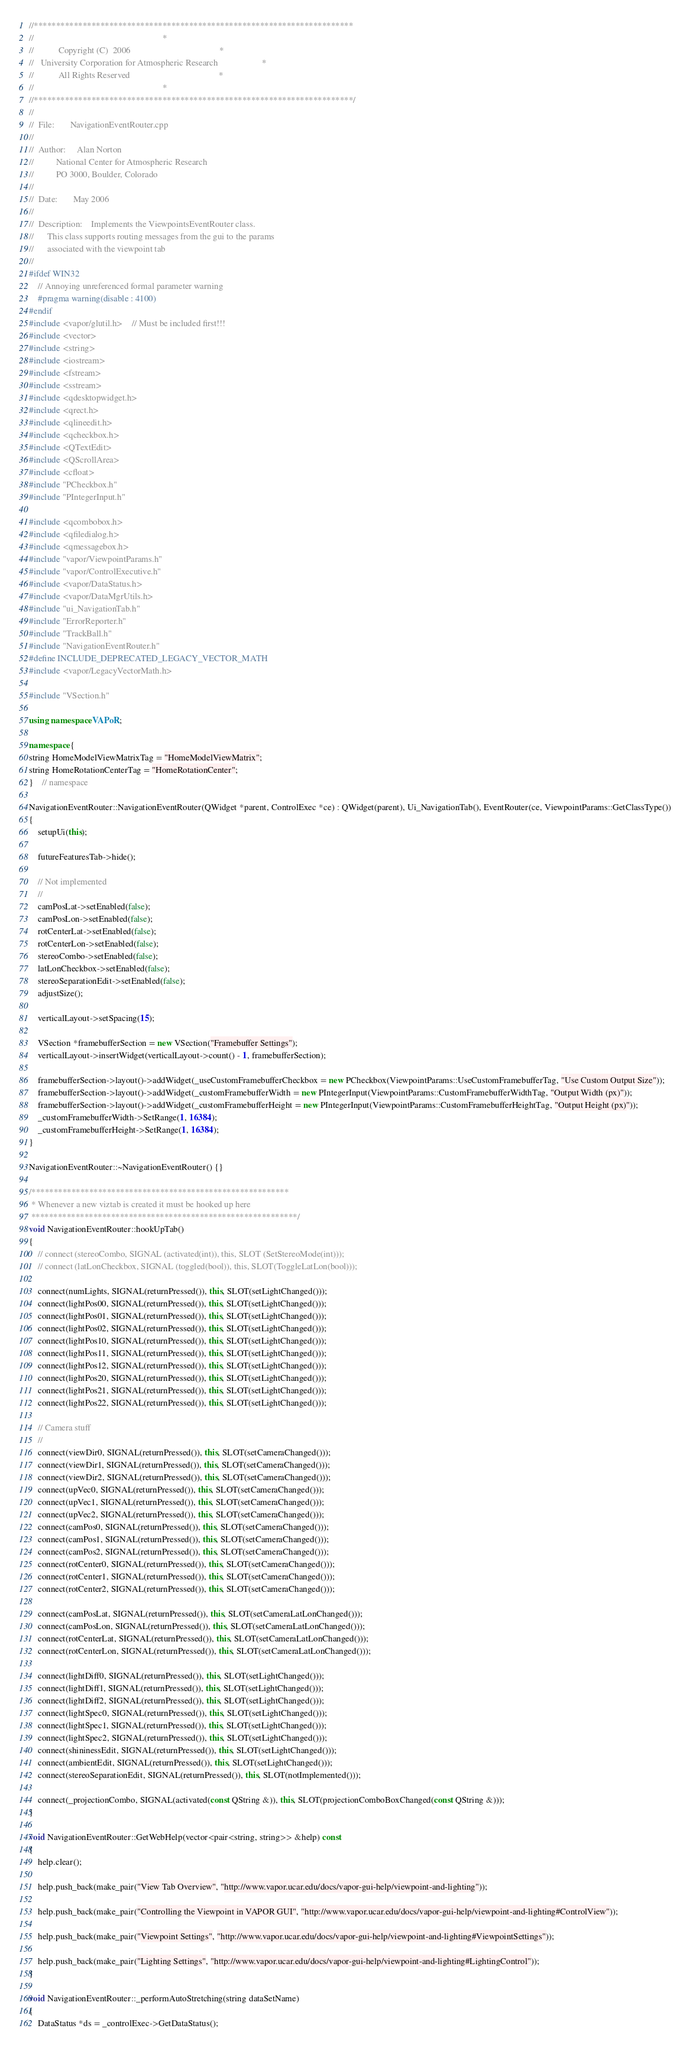Convert code to text. <code><loc_0><loc_0><loc_500><loc_500><_C++_>//************************************************************************
//															*
//			 Copyright (C)  2006										*
//	 University Corporation for Atmospheric Research					*
//			 All Rights Reserved										*
//															*
//************************************************************************/
//
//	File:		NavigationEventRouter.cpp
//
//	Author:		Alan Norton
//			National Center for Atmospheric Research
//			PO 3000, Boulder, Colorado
//
//	Date:		May 2006
//
//	Description:	Implements the ViewpointsEventRouter class.
//		This class supports routing messages from the gui to the params
//		associated with the viewpoint tab
//
#ifdef WIN32
    // Annoying unreferenced formal parameter warning
    #pragma warning(disable : 4100)
#endif
#include <vapor/glutil.h>    // Must be included first!!!
#include <vector>
#include <string>
#include <iostream>
#include <fstream>
#include <sstream>
#include <qdesktopwidget.h>
#include <qrect.h>
#include <qlineedit.h>
#include <qcheckbox.h>
#include <QTextEdit>
#include <QScrollArea>
#include <cfloat>
#include "PCheckbox.h"
#include "PIntegerInput.h"

#include <qcombobox.h>
#include <qfiledialog.h>
#include <qmessagebox.h>
#include "vapor/ViewpointParams.h"
#include "vapor/ControlExecutive.h"
#include <vapor/DataStatus.h>
#include <vapor/DataMgrUtils.h>
#include "ui_NavigationTab.h"
#include "ErrorReporter.h"
#include "TrackBall.h"
#include "NavigationEventRouter.h"
#define INCLUDE_DEPRECATED_LEGACY_VECTOR_MATH
#include <vapor/LegacyVectorMath.h>

#include "VSection.h"

using namespace VAPoR;

namespace {
string HomeModelViewMatrixTag = "HomeModelViewMatrix";
string HomeRotationCenterTag = "HomeRotationCenter";
}    // namespace

NavigationEventRouter::NavigationEventRouter(QWidget *parent, ControlExec *ce) : QWidget(parent), Ui_NavigationTab(), EventRouter(ce, ViewpointParams::GetClassType())
{
    setupUi(this);

    futureFeaturesTab->hide();

    // Not implemented
    //
    camPosLat->setEnabled(false);
    camPosLon->setEnabled(false);
    rotCenterLat->setEnabled(false);
    rotCenterLon->setEnabled(false);
    stereoCombo->setEnabled(false);
    latLonCheckbox->setEnabled(false);
    stereoSeparationEdit->setEnabled(false);
    adjustSize();

    verticalLayout->setSpacing(15);

    VSection *framebufferSection = new VSection("Framebuffer Settings");
    verticalLayout->insertWidget(verticalLayout->count() - 1, framebufferSection);

    framebufferSection->layout()->addWidget(_useCustomFramebufferCheckbox = new PCheckbox(ViewpointParams::UseCustomFramebufferTag, "Use Custom Output Size"));
    framebufferSection->layout()->addWidget(_customFramebufferWidth = new PIntegerInput(ViewpointParams::CustomFramebufferWidthTag, "Output Width (px)"));
    framebufferSection->layout()->addWidget(_customFramebufferHeight = new PIntegerInput(ViewpointParams::CustomFramebufferHeightTag, "Output Height (px)"));
    _customFramebufferWidth->SetRange(1, 16384);
    _customFramebufferHeight->SetRange(1, 16384);
}

NavigationEventRouter::~NavigationEventRouter() {}

/**********************************************************
 * Whenever a new viztab is created it must be hooked up here
 ************************************************************/
void NavigationEventRouter::hookUpTab()
{
    // connect (stereoCombo, SIGNAL (activated(int)), this, SLOT (SetStereoMode(int)));
    // connect (latLonCheckbox, SIGNAL (toggled(bool)), this, SLOT(ToggleLatLon(bool)));

    connect(numLights, SIGNAL(returnPressed()), this, SLOT(setLightChanged()));
    connect(lightPos00, SIGNAL(returnPressed()), this, SLOT(setLightChanged()));
    connect(lightPos01, SIGNAL(returnPressed()), this, SLOT(setLightChanged()));
    connect(lightPos02, SIGNAL(returnPressed()), this, SLOT(setLightChanged()));
    connect(lightPos10, SIGNAL(returnPressed()), this, SLOT(setLightChanged()));
    connect(lightPos11, SIGNAL(returnPressed()), this, SLOT(setLightChanged()));
    connect(lightPos12, SIGNAL(returnPressed()), this, SLOT(setLightChanged()));
    connect(lightPos20, SIGNAL(returnPressed()), this, SLOT(setLightChanged()));
    connect(lightPos21, SIGNAL(returnPressed()), this, SLOT(setLightChanged()));
    connect(lightPos22, SIGNAL(returnPressed()), this, SLOT(setLightChanged()));

    // Camera stuff
    //
    connect(viewDir0, SIGNAL(returnPressed()), this, SLOT(setCameraChanged()));
    connect(viewDir1, SIGNAL(returnPressed()), this, SLOT(setCameraChanged()));
    connect(viewDir2, SIGNAL(returnPressed()), this, SLOT(setCameraChanged()));
    connect(upVec0, SIGNAL(returnPressed()), this, SLOT(setCameraChanged()));
    connect(upVec1, SIGNAL(returnPressed()), this, SLOT(setCameraChanged()));
    connect(upVec2, SIGNAL(returnPressed()), this, SLOT(setCameraChanged()));
    connect(camPos0, SIGNAL(returnPressed()), this, SLOT(setCameraChanged()));
    connect(camPos1, SIGNAL(returnPressed()), this, SLOT(setCameraChanged()));
    connect(camPos2, SIGNAL(returnPressed()), this, SLOT(setCameraChanged()));
    connect(rotCenter0, SIGNAL(returnPressed()), this, SLOT(setCameraChanged()));
    connect(rotCenter1, SIGNAL(returnPressed()), this, SLOT(setCameraChanged()));
    connect(rotCenter2, SIGNAL(returnPressed()), this, SLOT(setCameraChanged()));

    connect(camPosLat, SIGNAL(returnPressed()), this, SLOT(setCameraLatLonChanged()));
    connect(camPosLon, SIGNAL(returnPressed()), this, SLOT(setCameraLatLonChanged()));
    connect(rotCenterLat, SIGNAL(returnPressed()), this, SLOT(setCameraLatLonChanged()));
    connect(rotCenterLon, SIGNAL(returnPressed()), this, SLOT(setCameraLatLonChanged()));

    connect(lightDiff0, SIGNAL(returnPressed()), this, SLOT(setLightChanged()));
    connect(lightDiff1, SIGNAL(returnPressed()), this, SLOT(setLightChanged()));
    connect(lightDiff2, SIGNAL(returnPressed()), this, SLOT(setLightChanged()));
    connect(lightSpec0, SIGNAL(returnPressed()), this, SLOT(setLightChanged()));
    connect(lightSpec1, SIGNAL(returnPressed()), this, SLOT(setLightChanged()));
    connect(lightSpec2, SIGNAL(returnPressed()), this, SLOT(setLightChanged()));
    connect(shininessEdit, SIGNAL(returnPressed()), this, SLOT(setLightChanged()));
    connect(ambientEdit, SIGNAL(returnPressed()), this, SLOT(setLightChanged()));
    connect(stereoSeparationEdit, SIGNAL(returnPressed()), this, SLOT(notImplemented()));

    connect(_projectionCombo, SIGNAL(activated(const QString &)), this, SLOT(projectionComboBoxChanged(const QString &)));
}

void NavigationEventRouter::GetWebHelp(vector<pair<string, string>> &help) const
{
    help.clear();

    help.push_back(make_pair("View Tab Overview", "http://www.vapor.ucar.edu/docs/vapor-gui-help/viewpoint-and-lighting"));

    help.push_back(make_pair("Controlling the Viewpoint in VAPOR GUI", "http://www.vapor.ucar.edu/docs/vapor-gui-help/viewpoint-and-lighting#ControlView"));

    help.push_back(make_pair("Viewpoint Settings", "http://www.vapor.ucar.edu/docs/vapor-gui-help/viewpoint-and-lighting#ViewpointSettings"));

    help.push_back(make_pair("Lighting Settings", "http://www.vapor.ucar.edu/docs/vapor-gui-help/viewpoint-and-lighting#LightingControl"));
}

void NavigationEventRouter::_performAutoStretching(string dataSetName)
{
    DataStatus *ds = _controlExec->GetDataStatus();
</code> 